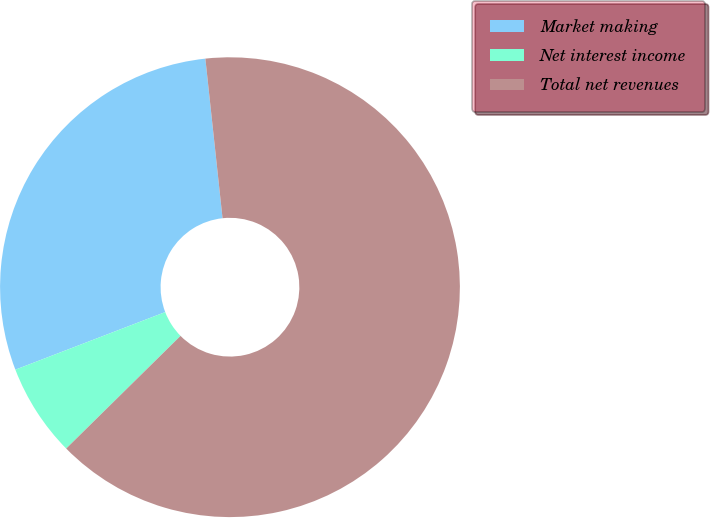Convert chart. <chart><loc_0><loc_0><loc_500><loc_500><pie_chart><fcel>Market making<fcel>Net interest income<fcel>Total net revenues<nl><fcel>29.13%<fcel>6.54%<fcel>64.32%<nl></chart> 